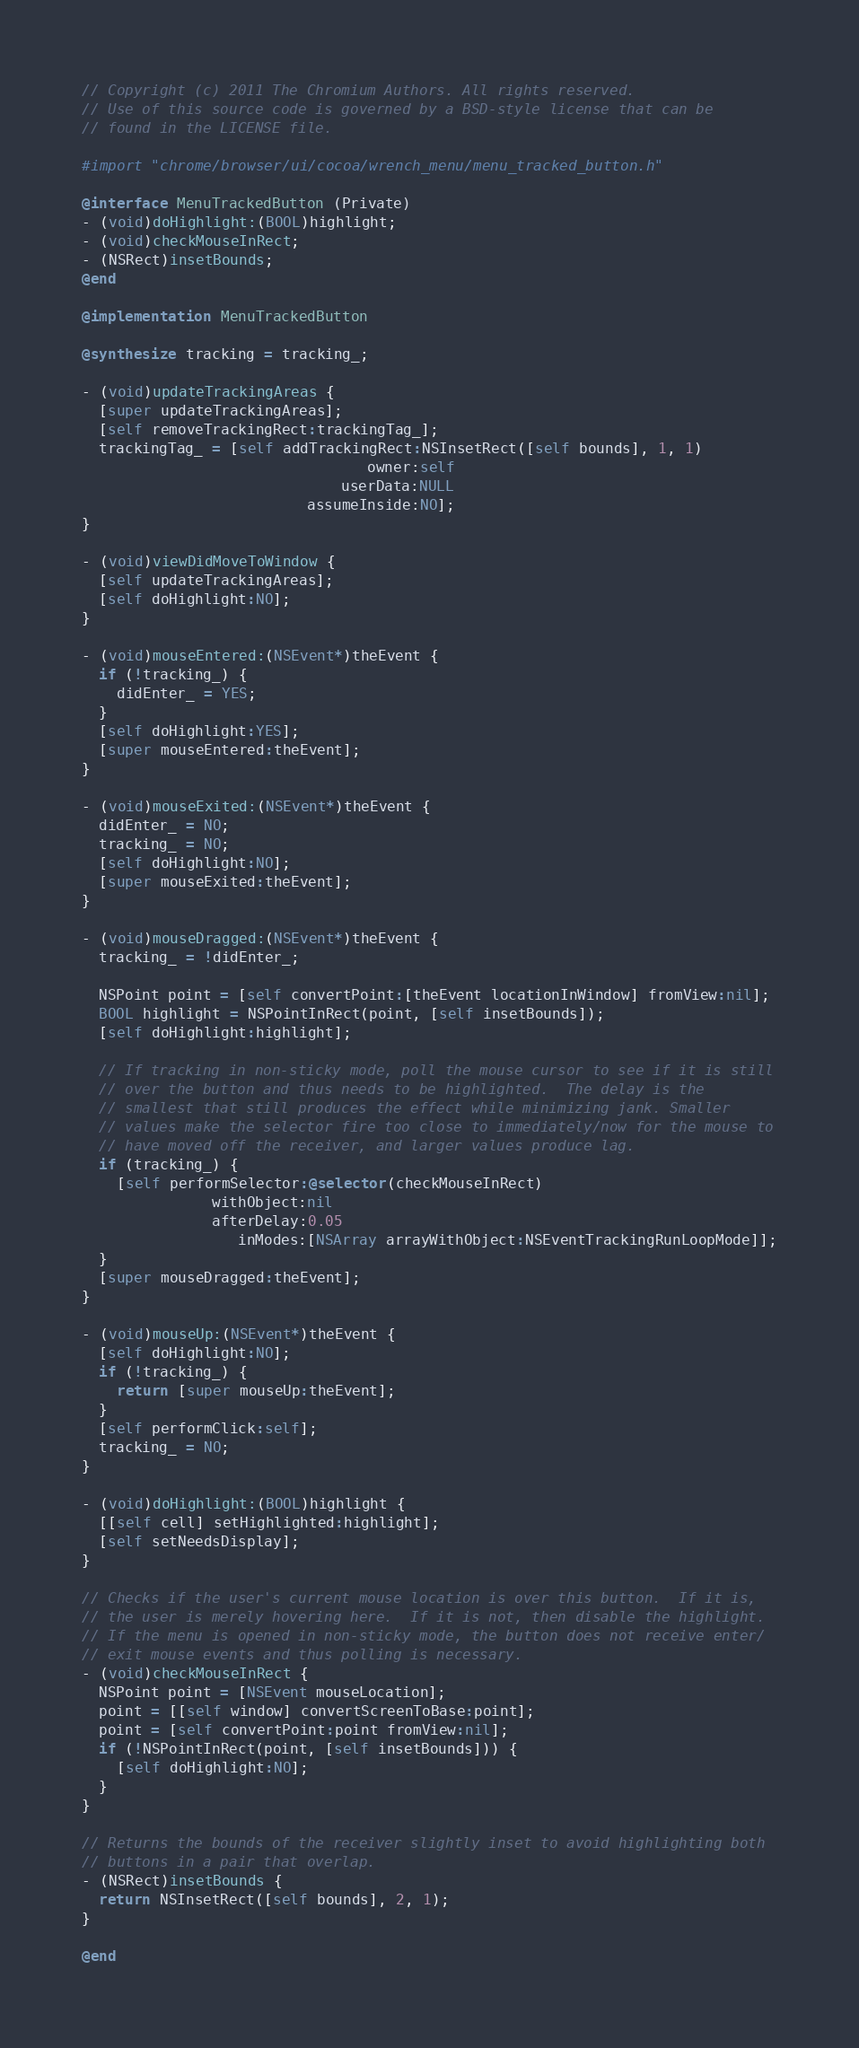Convert code to text. <code><loc_0><loc_0><loc_500><loc_500><_ObjectiveC_>// Copyright (c) 2011 The Chromium Authors. All rights reserved.
// Use of this source code is governed by a BSD-style license that can be
// found in the LICENSE file.

#import "chrome/browser/ui/cocoa/wrench_menu/menu_tracked_button.h"

@interface MenuTrackedButton (Private)
- (void)doHighlight:(BOOL)highlight;
- (void)checkMouseInRect;
- (NSRect)insetBounds;
@end

@implementation MenuTrackedButton

@synthesize tracking = tracking_;

- (void)updateTrackingAreas {
  [super updateTrackingAreas];
  [self removeTrackingRect:trackingTag_];
  trackingTag_ = [self addTrackingRect:NSInsetRect([self bounds], 1, 1)
                                 owner:self
                              userData:NULL
                          assumeInside:NO];
}

- (void)viewDidMoveToWindow {
  [self updateTrackingAreas];
  [self doHighlight:NO];
}

- (void)mouseEntered:(NSEvent*)theEvent {
  if (!tracking_) {
    didEnter_ = YES;
  }
  [self doHighlight:YES];
  [super mouseEntered:theEvent];
}

- (void)mouseExited:(NSEvent*)theEvent {
  didEnter_ = NO;
  tracking_ = NO;
  [self doHighlight:NO];
  [super mouseExited:theEvent];
}

- (void)mouseDragged:(NSEvent*)theEvent {
  tracking_ = !didEnter_;

  NSPoint point = [self convertPoint:[theEvent locationInWindow] fromView:nil];
  BOOL highlight = NSPointInRect(point, [self insetBounds]);
  [self doHighlight:highlight];

  // If tracking in non-sticky mode, poll the mouse cursor to see if it is still
  // over the button and thus needs to be highlighted.  The delay is the
  // smallest that still produces the effect while minimizing jank. Smaller
  // values make the selector fire too close to immediately/now for the mouse to
  // have moved off the receiver, and larger values produce lag.
  if (tracking_) {
    [self performSelector:@selector(checkMouseInRect)
               withObject:nil
               afterDelay:0.05
                  inModes:[NSArray arrayWithObject:NSEventTrackingRunLoopMode]];
  }
  [super mouseDragged:theEvent];
}

- (void)mouseUp:(NSEvent*)theEvent {
  [self doHighlight:NO];
  if (!tracking_) {
    return [super mouseUp:theEvent];
  }
  [self performClick:self];
  tracking_ = NO;
}

- (void)doHighlight:(BOOL)highlight {
  [[self cell] setHighlighted:highlight];
  [self setNeedsDisplay];
}

// Checks if the user's current mouse location is over this button.  If it is,
// the user is merely hovering here.  If it is not, then disable the highlight.
// If the menu is opened in non-sticky mode, the button does not receive enter/
// exit mouse events and thus polling is necessary.
- (void)checkMouseInRect {
  NSPoint point = [NSEvent mouseLocation];
  point = [[self window] convertScreenToBase:point];
  point = [self convertPoint:point fromView:nil];
  if (!NSPointInRect(point, [self insetBounds])) {
    [self doHighlight:NO];
  }
}

// Returns the bounds of the receiver slightly inset to avoid highlighting both
// buttons in a pair that overlap.
- (NSRect)insetBounds {
  return NSInsetRect([self bounds], 2, 1);
}

@end
</code> 